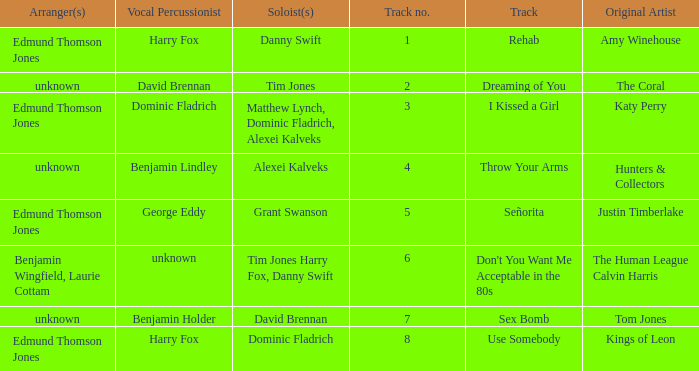Who is the vocal percussionist for Sex Bomb? Benjamin Holder. Could you help me parse every detail presented in this table? {'header': ['Arranger(s)', 'Vocal Percussionist', 'Soloist(s)', 'Track no.', 'Track', 'Original Artist'], 'rows': [['Edmund Thomson Jones', 'Harry Fox', 'Danny Swift', '1', 'Rehab', 'Amy Winehouse'], ['unknown', 'David Brennan', 'Tim Jones', '2', 'Dreaming of You', 'The Coral'], ['Edmund Thomson Jones', 'Dominic Fladrich', 'Matthew Lynch, Dominic Fladrich, Alexei Kalveks', '3', 'I Kissed a Girl', 'Katy Perry'], ['unknown', 'Benjamin Lindley', 'Alexei Kalveks', '4', 'Throw Your Arms', 'Hunters & Collectors'], ['Edmund Thomson Jones', 'George Eddy', 'Grant Swanson', '5', 'Señorita', 'Justin Timberlake'], ['Benjamin Wingfield, Laurie Cottam', 'unknown', 'Tim Jones Harry Fox, Danny Swift', '6', "Don't You Want Me Acceptable in the 80s", 'The Human League Calvin Harris'], ['unknown', 'Benjamin Holder', 'David Brennan', '7', 'Sex Bomb', 'Tom Jones'], ['Edmund Thomson Jones', 'Harry Fox', 'Dominic Fladrich', '8', 'Use Somebody', 'Kings of Leon']]} 